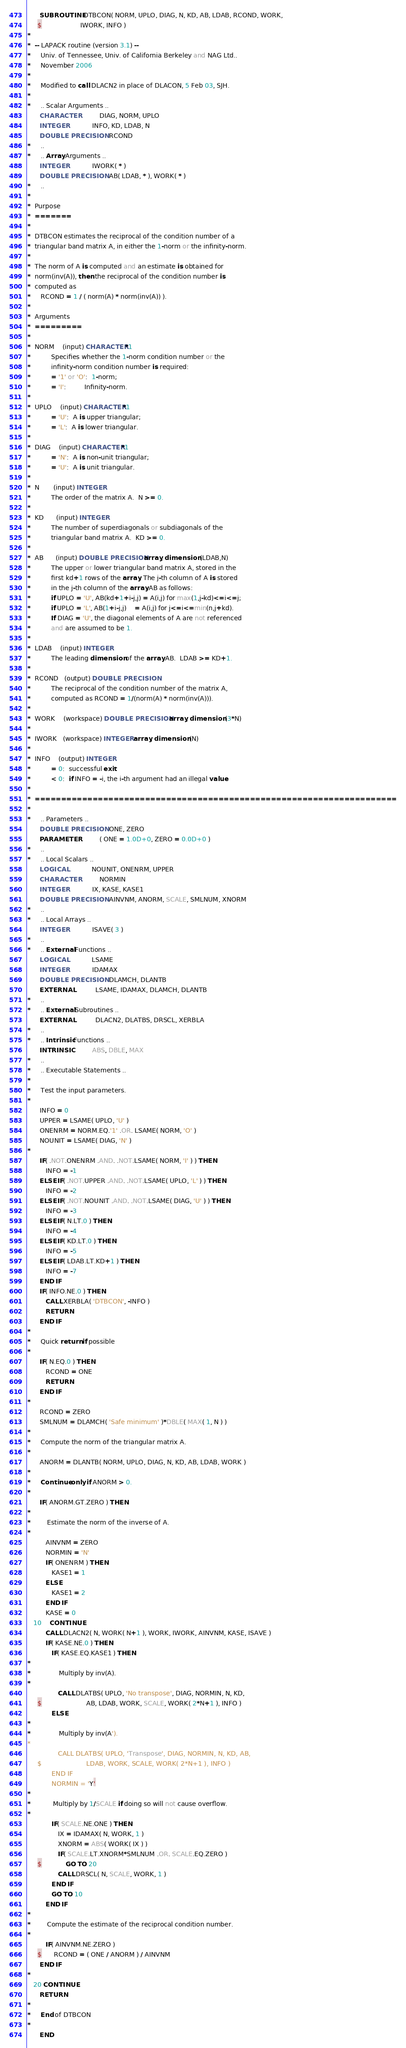Convert code to text. <code><loc_0><loc_0><loc_500><loc_500><_FORTRAN_>      SUBROUTINE DTBCON( NORM, UPLO, DIAG, N, KD, AB, LDAB, RCOND, WORK,
     $                   IWORK, INFO )
*
*  -- LAPACK routine (version 3.1) --
*     Univ. of Tennessee, Univ. of California Berkeley and NAG Ltd..
*     November 2006
*
*     Modified to call DLACN2 in place of DLACON, 5 Feb 03, SJH.
*
*     .. Scalar Arguments ..
      CHARACTER          DIAG, NORM, UPLO
      INTEGER            INFO, KD, LDAB, N
      DOUBLE PRECISION   RCOND
*     ..
*     .. Array Arguments ..
      INTEGER            IWORK( * )
      DOUBLE PRECISION   AB( LDAB, * ), WORK( * )
*     ..
*
*  Purpose
*  =======
*
*  DTBCON estimates the reciprocal of the condition number of a
*  triangular band matrix A, in either the 1-norm or the infinity-norm.
*
*  The norm of A is computed and an estimate is obtained for
*  norm(inv(A)), then the reciprocal of the condition number is
*  computed as
*     RCOND = 1 / ( norm(A) * norm(inv(A)) ).
*
*  Arguments
*  =========
*
*  NORM    (input) CHARACTER*1
*          Specifies whether the 1-norm condition number or the
*          infinity-norm condition number is required:
*          = '1' or 'O':  1-norm;
*          = 'I':         Infinity-norm.
*
*  UPLO    (input) CHARACTER*1
*          = 'U':  A is upper triangular;
*          = 'L':  A is lower triangular.
*
*  DIAG    (input) CHARACTER*1
*          = 'N':  A is non-unit triangular;
*          = 'U':  A is unit triangular.
*
*  N       (input) INTEGER
*          The order of the matrix A.  N >= 0.
*
*  KD      (input) INTEGER
*          The number of superdiagonals or subdiagonals of the
*          triangular band matrix A.  KD >= 0.
*
*  AB      (input) DOUBLE PRECISION array, dimension (LDAB,N)
*          The upper or lower triangular band matrix A, stored in the
*          first kd+1 rows of the array. The j-th column of A is stored
*          in the j-th column of the array AB as follows:
*          if UPLO = 'U', AB(kd+1+i-j,j) = A(i,j) for max(1,j-kd)<=i<=j;
*          if UPLO = 'L', AB(1+i-j,j)    = A(i,j) for j<=i<=min(n,j+kd).
*          If DIAG = 'U', the diagonal elements of A are not referenced
*          and are assumed to be 1.
*
*  LDAB    (input) INTEGER
*          The leading dimension of the array AB.  LDAB >= KD+1.
*
*  RCOND   (output) DOUBLE PRECISION
*          The reciprocal of the condition number of the matrix A,
*          computed as RCOND = 1/(norm(A) * norm(inv(A))).
*
*  WORK    (workspace) DOUBLE PRECISION array, dimension (3*N)
*
*  IWORK   (workspace) INTEGER array, dimension (N)
*
*  INFO    (output) INTEGER
*          = 0:  successful exit
*          < 0:  if INFO = -i, the i-th argument had an illegal value
*
*  =====================================================================
*
*     .. Parameters ..
      DOUBLE PRECISION   ONE, ZERO
      PARAMETER          ( ONE = 1.0D+0, ZERO = 0.0D+0 )
*     ..
*     .. Local Scalars ..
      LOGICAL            NOUNIT, ONENRM, UPPER
      CHARACTER          NORMIN
      INTEGER            IX, KASE, KASE1
      DOUBLE PRECISION   AINVNM, ANORM, SCALE, SMLNUM, XNORM
*     ..
*     .. Local Arrays ..
      INTEGER            ISAVE( 3 )
*     ..
*     .. External Functions ..
      LOGICAL            LSAME
      INTEGER            IDAMAX
      DOUBLE PRECISION   DLAMCH, DLANTB
      EXTERNAL           LSAME, IDAMAX, DLAMCH, DLANTB
*     ..
*     .. External Subroutines ..
      EXTERNAL           DLACN2, DLATBS, DRSCL, XERBLA
*     ..
*     .. Intrinsic Functions ..
      INTRINSIC          ABS, DBLE, MAX
*     ..
*     .. Executable Statements ..
*
*     Test the input parameters.
*
      INFO = 0
      UPPER = LSAME( UPLO, 'U' )
      ONENRM = NORM.EQ.'1' .OR. LSAME( NORM, 'O' )
      NOUNIT = LSAME( DIAG, 'N' )
*
      IF( .NOT.ONENRM .AND. .NOT.LSAME( NORM, 'I' ) ) THEN
         INFO = -1
      ELSE IF( .NOT.UPPER .AND. .NOT.LSAME( UPLO, 'L' ) ) THEN
         INFO = -2
      ELSE IF( .NOT.NOUNIT .AND. .NOT.LSAME( DIAG, 'U' ) ) THEN
         INFO = -3
      ELSE IF( N.LT.0 ) THEN
         INFO = -4
      ELSE IF( KD.LT.0 ) THEN
         INFO = -5
      ELSE IF( LDAB.LT.KD+1 ) THEN
         INFO = -7
      END IF
      IF( INFO.NE.0 ) THEN
         CALL XERBLA( 'DTBCON', -INFO )
         RETURN
      END IF
*
*     Quick return if possible
*
      IF( N.EQ.0 ) THEN
         RCOND = ONE
         RETURN
      END IF
*
      RCOND = ZERO
      SMLNUM = DLAMCH( 'Safe minimum' )*DBLE( MAX( 1, N ) )
*
*     Compute the norm of the triangular matrix A.
*
      ANORM = DLANTB( NORM, UPLO, DIAG, N, KD, AB, LDAB, WORK )
*
*     Continue only if ANORM > 0.
*
      IF( ANORM.GT.ZERO ) THEN
*
*        Estimate the norm of the inverse of A.
*
         AINVNM = ZERO
         NORMIN = 'N'
         IF( ONENRM ) THEN
            KASE1 = 1
         ELSE
            KASE1 = 2
         END IF
         KASE = 0
   10    CONTINUE
         CALL DLACN2( N, WORK( N+1 ), WORK, IWORK, AINVNM, KASE, ISAVE )
         IF( KASE.NE.0 ) THEN
            IF( KASE.EQ.KASE1 ) THEN
*
*              Multiply by inv(A).
*
               CALL DLATBS( UPLO, 'No transpose', DIAG, NORMIN, N, KD,
     $                      AB, LDAB, WORK, SCALE, WORK( 2*N+1 ), INFO )
            ELSE
*
*              Multiply by inv(A').
*
               CALL DLATBS( UPLO, 'Transpose', DIAG, NORMIN, N, KD, AB,
     $                      LDAB, WORK, SCALE, WORK( 2*N+1 ), INFO )
            END IF
            NORMIN = 'Y'
*
*           Multiply by 1/SCALE if doing so will not cause overflow.
*
            IF( SCALE.NE.ONE ) THEN
               IX = IDAMAX( N, WORK, 1 )
               XNORM = ABS( WORK( IX ) )
               IF( SCALE.LT.XNORM*SMLNUM .OR. SCALE.EQ.ZERO )
     $            GO TO 20
               CALL DRSCL( N, SCALE, WORK, 1 )
            END IF
            GO TO 10
         END IF
*
*        Compute the estimate of the reciprocal condition number.
*
         IF( AINVNM.NE.ZERO )
     $      RCOND = ( ONE / ANORM ) / AINVNM
      END IF
*
   20 CONTINUE
      RETURN
*
*     End of DTBCON
*
      END
</code> 